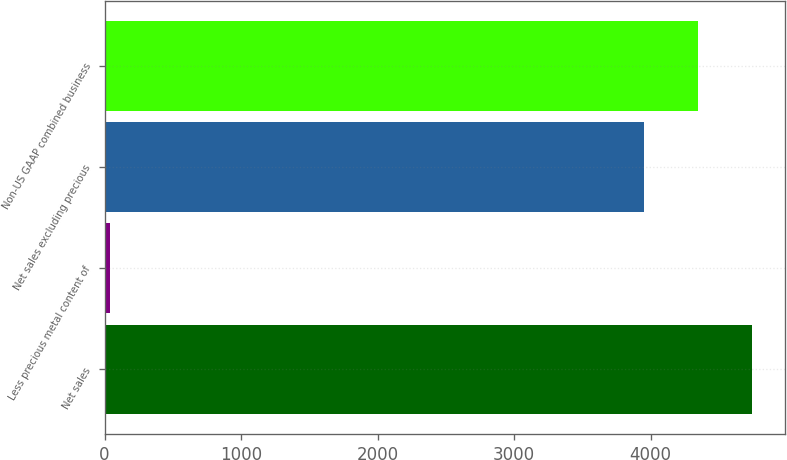Convert chart. <chart><loc_0><loc_0><loc_500><loc_500><bar_chart><fcel>Net sales<fcel>Less precious metal content of<fcel>Net sales excluding precious<fcel>Non-US GAAP combined business<nl><fcel>4743.48<fcel>40.5<fcel>3952.9<fcel>4348.19<nl></chart> 